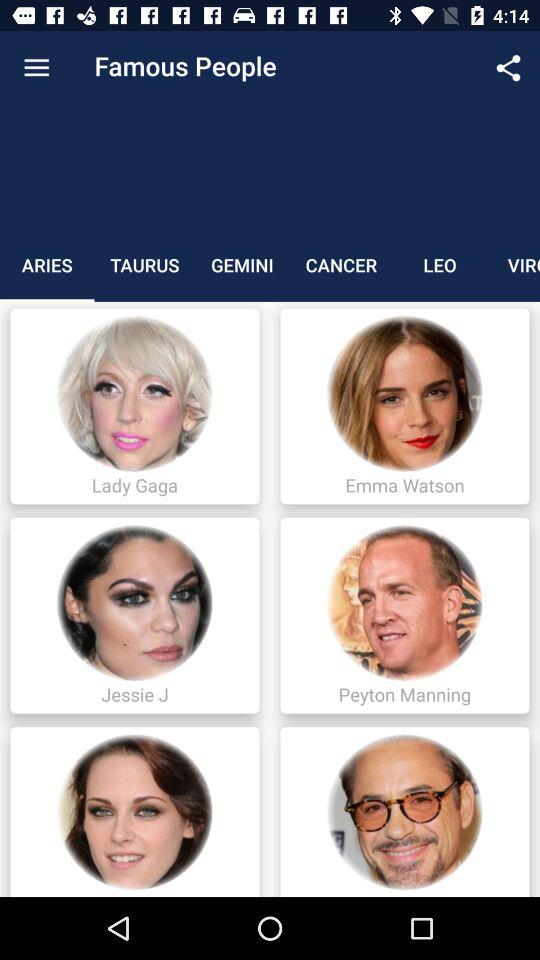What are the names of the famous people with the sign of Aries? The names of the famous people with the sign of Aries are Lady Gaga, Emma Watson, Jessie J. and Peyton Manning. 